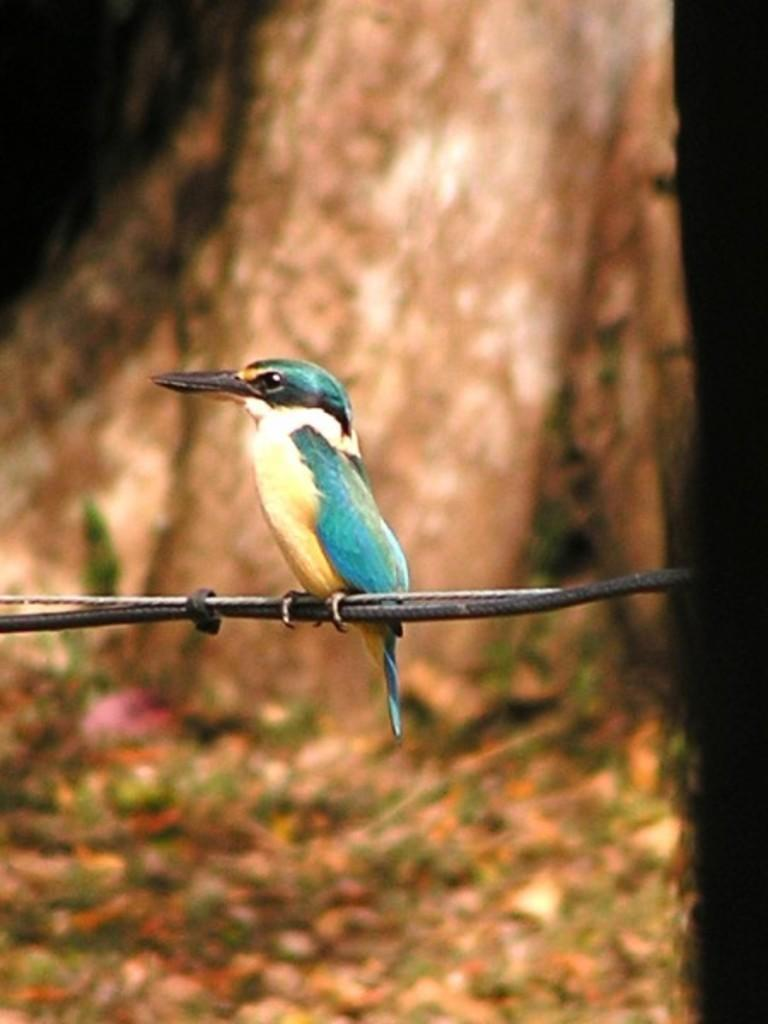What is on the wire in the image? There is a bird on the wire in the image. Can you describe the bird's appearance? The bird has green, white, black, and light yellow colors. What might be visible in the background of the image? There might be a tree bark visible in the background of the image. How many chairs are visible in the image? There are no chairs present in the image. Can you tell me the breed of the rabbit in the image? There is no rabbit present in the image. 